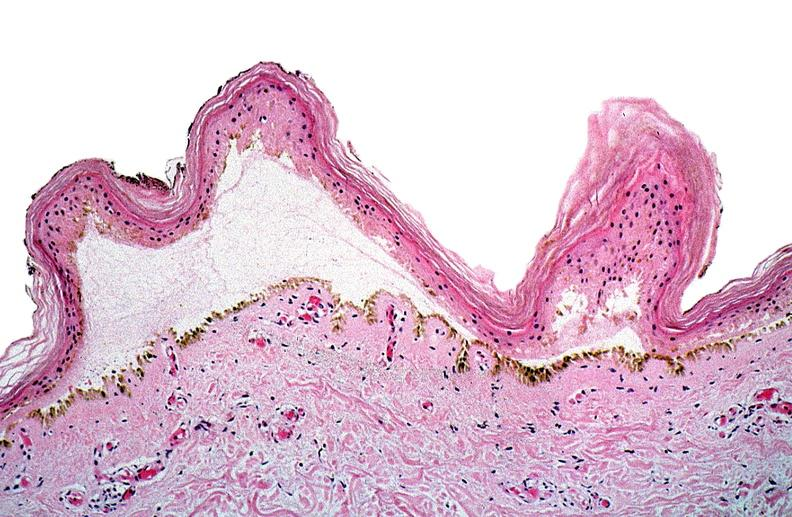where is this?
Answer the question using a single word or phrase. Skin 